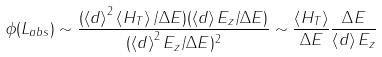Convert formula to latex. <formula><loc_0><loc_0><loc_500><loc_500>\phi ( L _ { a b s } ) \sim \frac { ( \left \langle d \right \rangle ^ { 2 } \left \langle H _ { T } \right \rangle / \Delta E ) ( \left \langle d \right \rangle E _ { z } / \Delta E ) } { ( \left \langle d \right \rangle ^ { 2 } E _ { z } / \Delta E ) ^ { 2 } } \sim \frac { \left \langle H _ { T } \right \rangle } { \Delta E } \frac { \Delta E } { \left \langle d \right \rangle E _ { z } }</formula> 